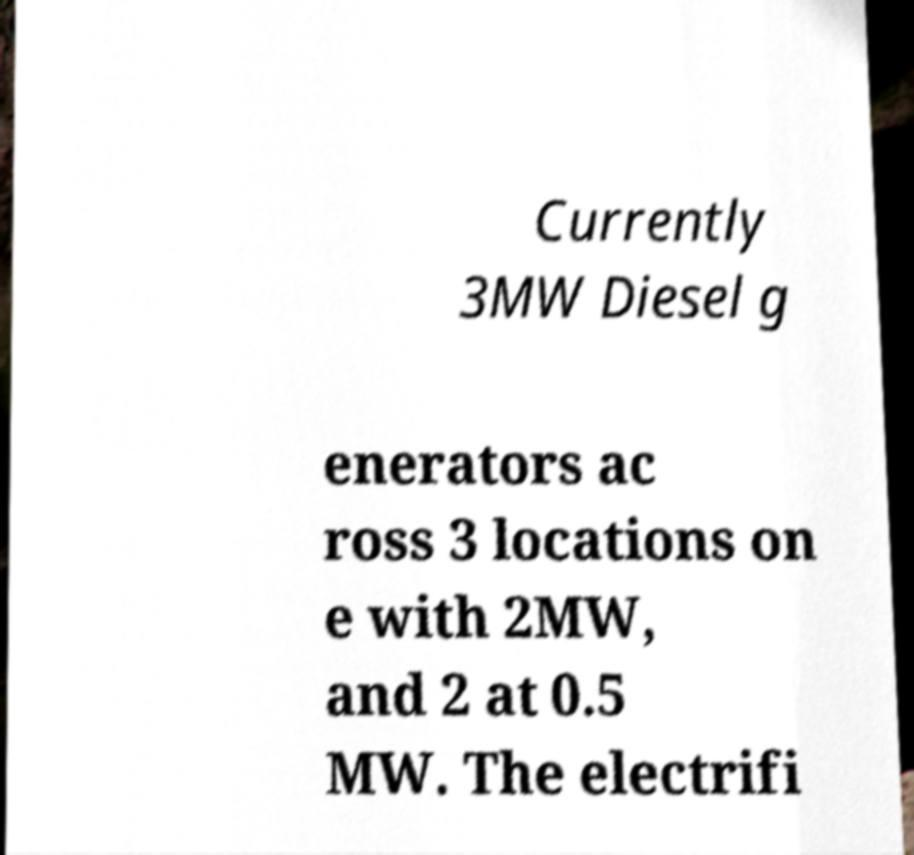Please read and relay the text visible in this image. What does it say? Currently 3MW Diesel g enerators ac ross 3 locations on e with 2MW, and 2 at 0.5 MW. The electrifi 